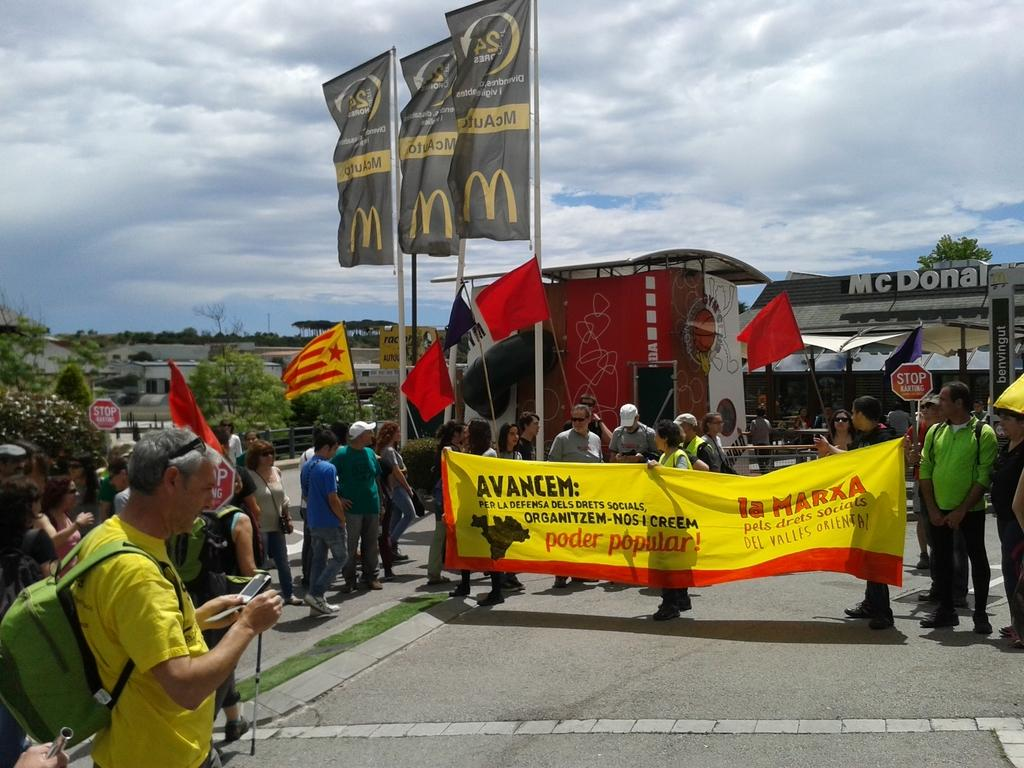Provide a one-sentence caption for the provided image. People walk carrying an AVANCEM banner that is yellow. 